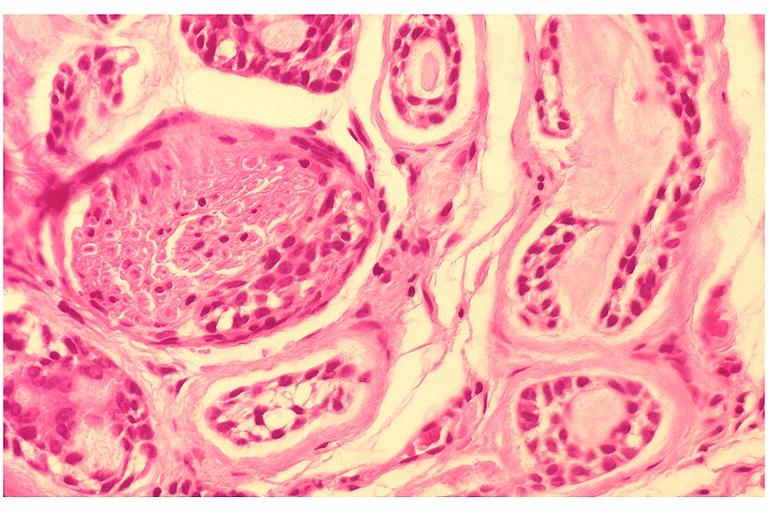where is this?
Answer the question using a single word or phrase. Oral 